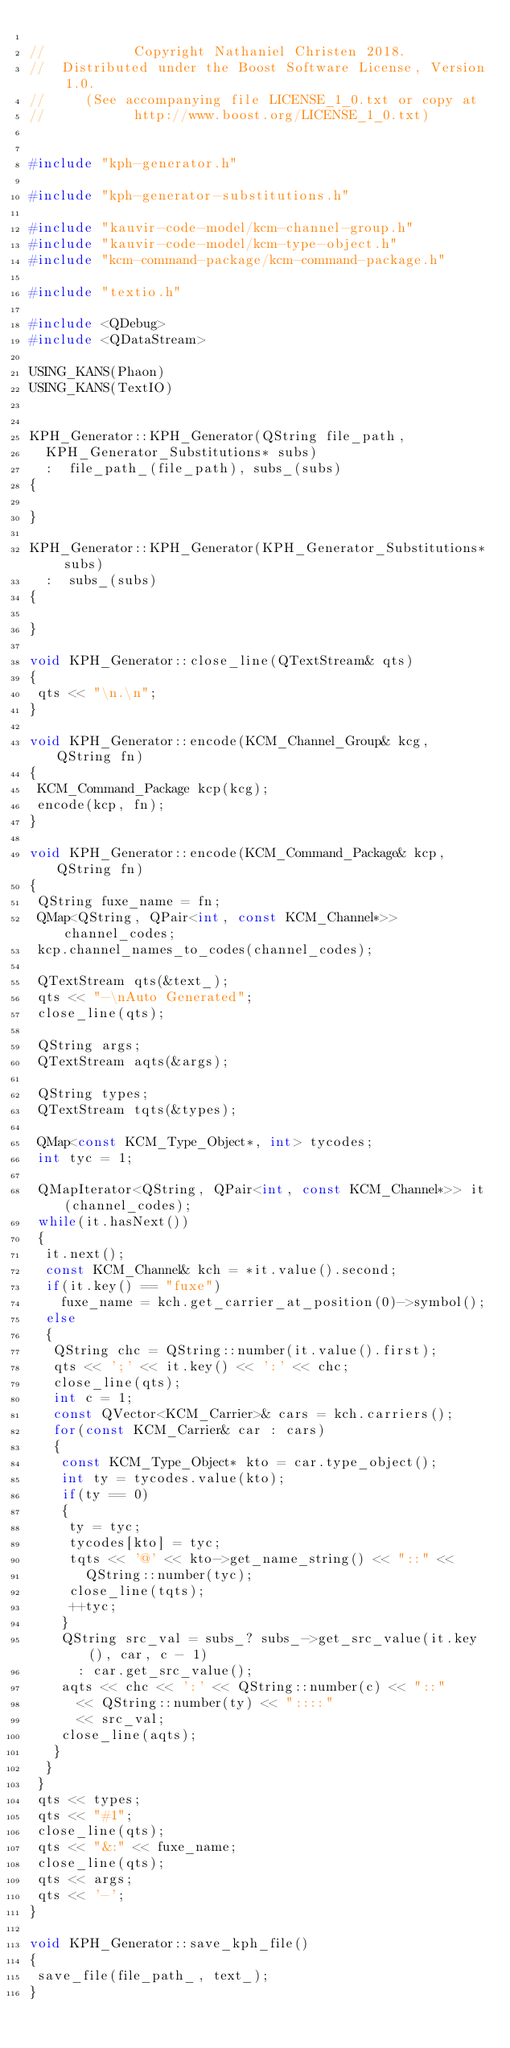<code> <loc_0><loc_0><loc_500><loc_500><_C++_>
//           Copyright Nathaniel Christen 2018.
//  Distributed under the Boost Software License, Version 1.0.
//     (See accompanying file LICENSE_1_0.txt or copy at
//           http://www.boost.org/LICENSE_1_0.txt)


#include "kph-generator.h"

#include "kph-generator-substitutions.h"

#include "kauvir-code-model/kcm-channel-group.h"
#include "kauvir-code-model/kcm-type-object.h"
#include "kcm-command-package/kcm-command-package.h"

#include "textio.h"

#include <QDebug>
#include <QDataStream>

USING_KANS(Phaon)
USING_KANS(TextIO)


KPH_Generator::KPH_Generator(QString file_path,
  KPH_Generator_Substitutions* subs)
  :  file_path_(file_path), subs_(subs)
{

}

KPH_Generator::KPH_Generator(KPH_Generator_Substitutions* subs)
  :  subs_(subs)
{

}

void KPH_Generator::close_line(QTextStream& qts)
{
 qts << "\n.\n";
}

void KPH_Generator::encode(KCM_Channel_Group& kcg, QString fn)
{
 KCM_Command_Package kcp(kcg);
 encode(kcp, fn);
}

void KPH_Generator::encode(KCM_Command_Package& kcp, QString fn)
{
 QString fuxe_name = fn;
 QMap<QString, QPair<int, const KCM_Channel*>> channel_codes;
 kcp.channel_names_to_codes(channel_codes);

 QTextStream qts(&text_);
 qts << "-\nAuto Generated";
 close_line(qts);

 QString args;
 QTextStream aqts(&args);

 QString types;
 QTextStream tqts(&types);

 QMap<const KCM_Type_Object*, int> tycodes;
 int tyc = 1;

 QMapIterator<QString, QPair<int, const KCM_Channel*>> it(channel_codes);
 while(it.hasNext())
 {
  it.next();
  const KCM_Channel& kch = *it.value().second;
  if(it.key() == "fuxe")
    fuxe_name = kch.get_carrier_at_position(0)->symbol();
  else
  {
   QString chc = QString::number(it.value().first);
   qts << ';' << it.key() << ':' << chc;
   close_line(qts);
   int c = 1;
   const QVector<KCM_Carrier>& cars = kch.carriers();
   for(const KCM_Carrier& car : cars)
   {
    const KCM_Type_Object* kto = car.type_object();
    int ty = tycodes.value(kto);
    if(ty == 0)
    {
     ty = tyc;
     tycodes[kto] = tyc;
     tqts << '@' << kto->get_name_string() << "::" <<
       QString::number(tyc);
     close_line(tqts);
     ++tyc;
    }
    QString src_val = subs_? subs_->get_src_value(it.key(), car, c - 1)
      : car.get_src_value();
    aqts << chc << ':' << QString::number(c) << "::"
      << QString::number(ty) << "::::"
      << src_val;
    close_line(aqts);
   }
  }
 }
 qts << types;
 qts << "#1";
 close_line(qts);
 qts << "&:" << fuxe_name;
 close_line(qts);
 qts << args;
 qts << '-';
}

void KPH_Generator::save_kph_file()
{
 save_file(file_path_, text_);
}
</code> 